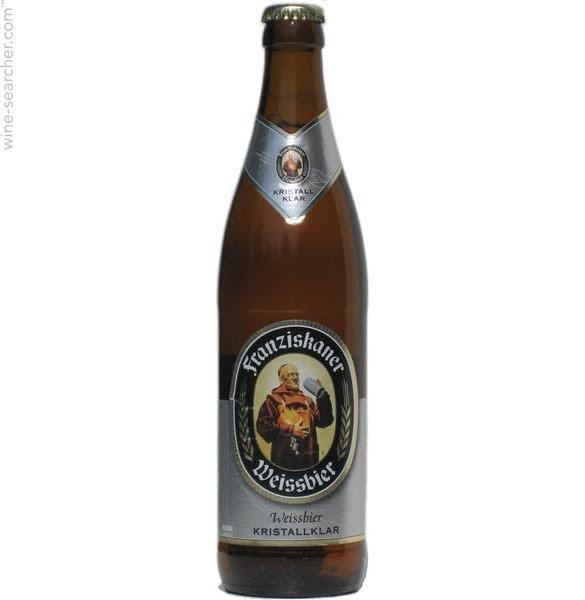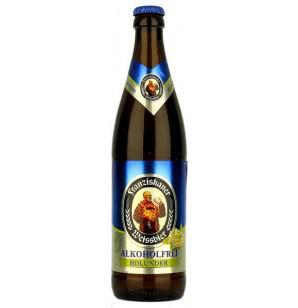The first image is the image on the left, the second image is the image on the right. Evaluate the accuracy of this statement regarding the images: "The left image contains both a bottle and a glass.". Is it true? Answer yes or no. No. The first image is the image on the left, the second image is the image on the right. Assess this claim about the two images: "In one image, a glass of ale is sitting next to a bottle of ale.". Correct or not? Answer yes or no. No. 